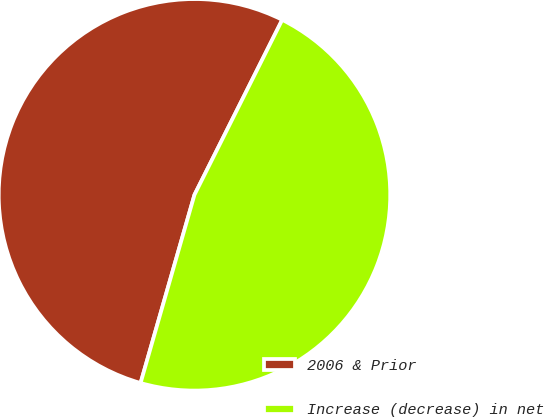Convert chart. <chart><loc_0><loc_0><loc_500><loc_500><pie_chart><fcel>2006 & Prior<fcel>Increase (decrease) in net<nl><fcel>52.96%<fcel>47.04%<nl></chart> 